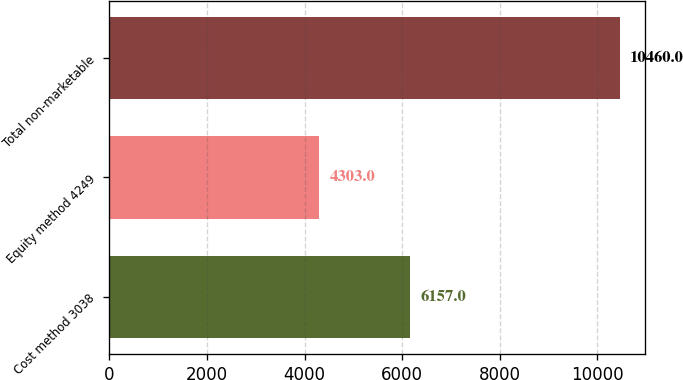Convert chart. <chart><loc_0><loc_0><loc_500><loc_500><bar_chart><fcel>Cost method 3038<fcel>Equity method 4249<fcel>Total non-marketable<nl><fcel>6157<fcel>4303<fcel>10460<nl></chart> 